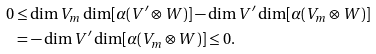<formula> <loc_0><loc_0><loc_500><loc_500>0 \leq & \dim V _ { m } \dim [ \alpha ( V ^ { \prime } \otimes W ) ] - \dim V ^ { \prime } \dim [ \alpha ( V _ { m } \otimes W ) ] \\ = & - \dim V ^ { \prime } \dim [ \alpha ( V _ { m } \otimes W ) ] \leq 0 .</formula> 